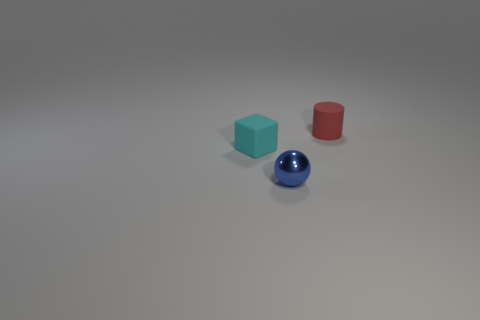Add 3 metal spheres. How many objects exist? 6 Subtract all cylinders. How many objects are left? 2 Subtract 0 gray balls. How many objects are left? 3 Subtract all small red objects. Subtract all blue metallic objects. How many objects are left? 1 Add 1 metal objects. How many metal objects are left? 2 Add 3 red objects. How many red objects exist? 4 